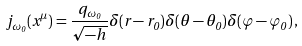Convert formula to latex. <formula><loc_0><loc_0><loc_500><loc_500>j _ { \omega _ { 0 } } ( x ^ { \mu } ) = \frac { q _ { \omega _ { 0 } } } { \sqrt { - h \, } } \delta ( r - r _ { 0 } ) \delta ( \theta - \theta _ { 0 } ) \delta ( \varphi - \varphi _ { 0 } ) \, ,</formula> 